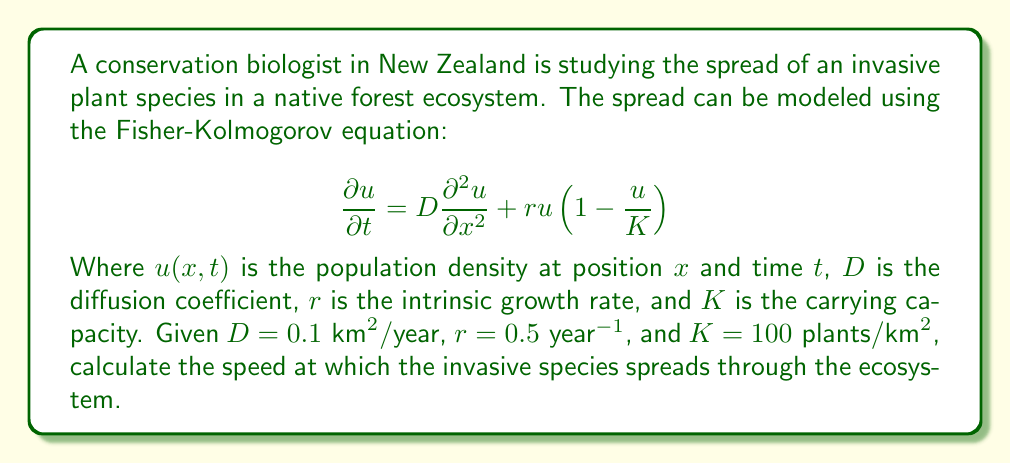Show me your answer to this math problem. To solve this problem, we'll follow these steps:

1) The Fisher-Kolmogorov equation is a reaction-diffusion equation that models the spread of a population. For a traveling wave solution, the speed of propagation is given by:

   $$c = 2\sqrt{rD}$$

   Where $c$ is the speed of propagation, $r$ is the intrinsic growth rate, and $D$ is the diffusion coefficient.

2) We are given:
   $D = 0.1 \text{ km}^2/\text{year}$
   $r = 0.5 \text{ year}^{-1}$

3) Let's substitute these values into the equation:

   $$c = 2\sqrt{(0.5 \text{ year}^{-1})(0.1 \text{ km}^2/\text{year})}$$

4) Simplify inside the square root:

   $$c = 2\sqrt{0.05 \text{ km}^2/\text{year}^2}$$

5) Calculate the square root:

   $$c = 2(0.2236 \text{ km}/\text{year})$$

6) Multiply:

   $$c = 0.4472 \text{ km}/\text{year}$$

7) Round to three decimal places:

   $$c \approx 0.447 \text{ km}/\text{year}$$

This means the invasive species is spreading at a rate of approximately 0.447 kilometers per year.
Answer: 0.447 km/year 